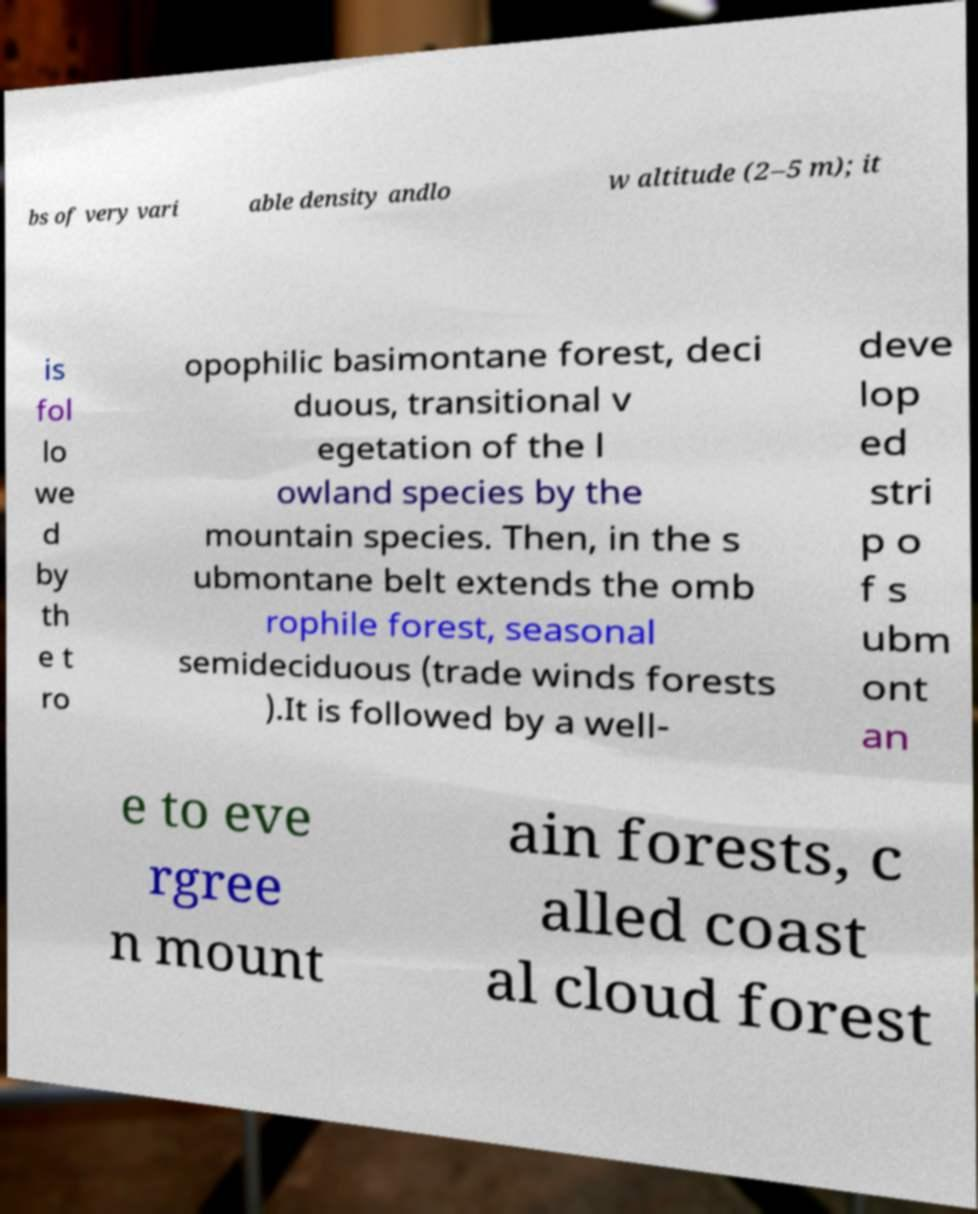There's text embedded in this image that I need extracted. Can you transcribe it verbatim? bs of very vari able density andlo w altitude (2–5 m); it is fol lo we d by th e t ro opophilic basimontane forest, deci duous, transitional v egetation of the l owland species by the mountain species. Then, in the s ubmontane belt extends the omb rophile forest, seasonal semideciduous (trade winds forests ).It is followed by a well- deve lop ed stri p o f s ubm ont an e to eve rgree n mount ain forests, c alled coast al cloud forest 